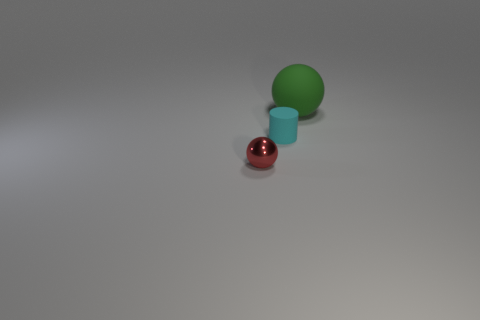Subtract all red spheres. How many spheres are left? 1 Add 1 big blue blocks. How many objects exist? 4 Subtract all cylinders. How many objects are left? 2 Add 2 tiny cylinders. How many tiny cylinders are left? 3 Add 2 green matte spheres. How many green matte spheres exist? 3 Subtract 1 green balls. How many objects are left? 2 Subtract all cyan balls. Subtract all red cylinders. How many balls are left? 2 Subtract all brown cubes. How many cyan balls are left? 0 Subtract all red metallic balls. Subtract all rubber balls. How many objects are left? 1 